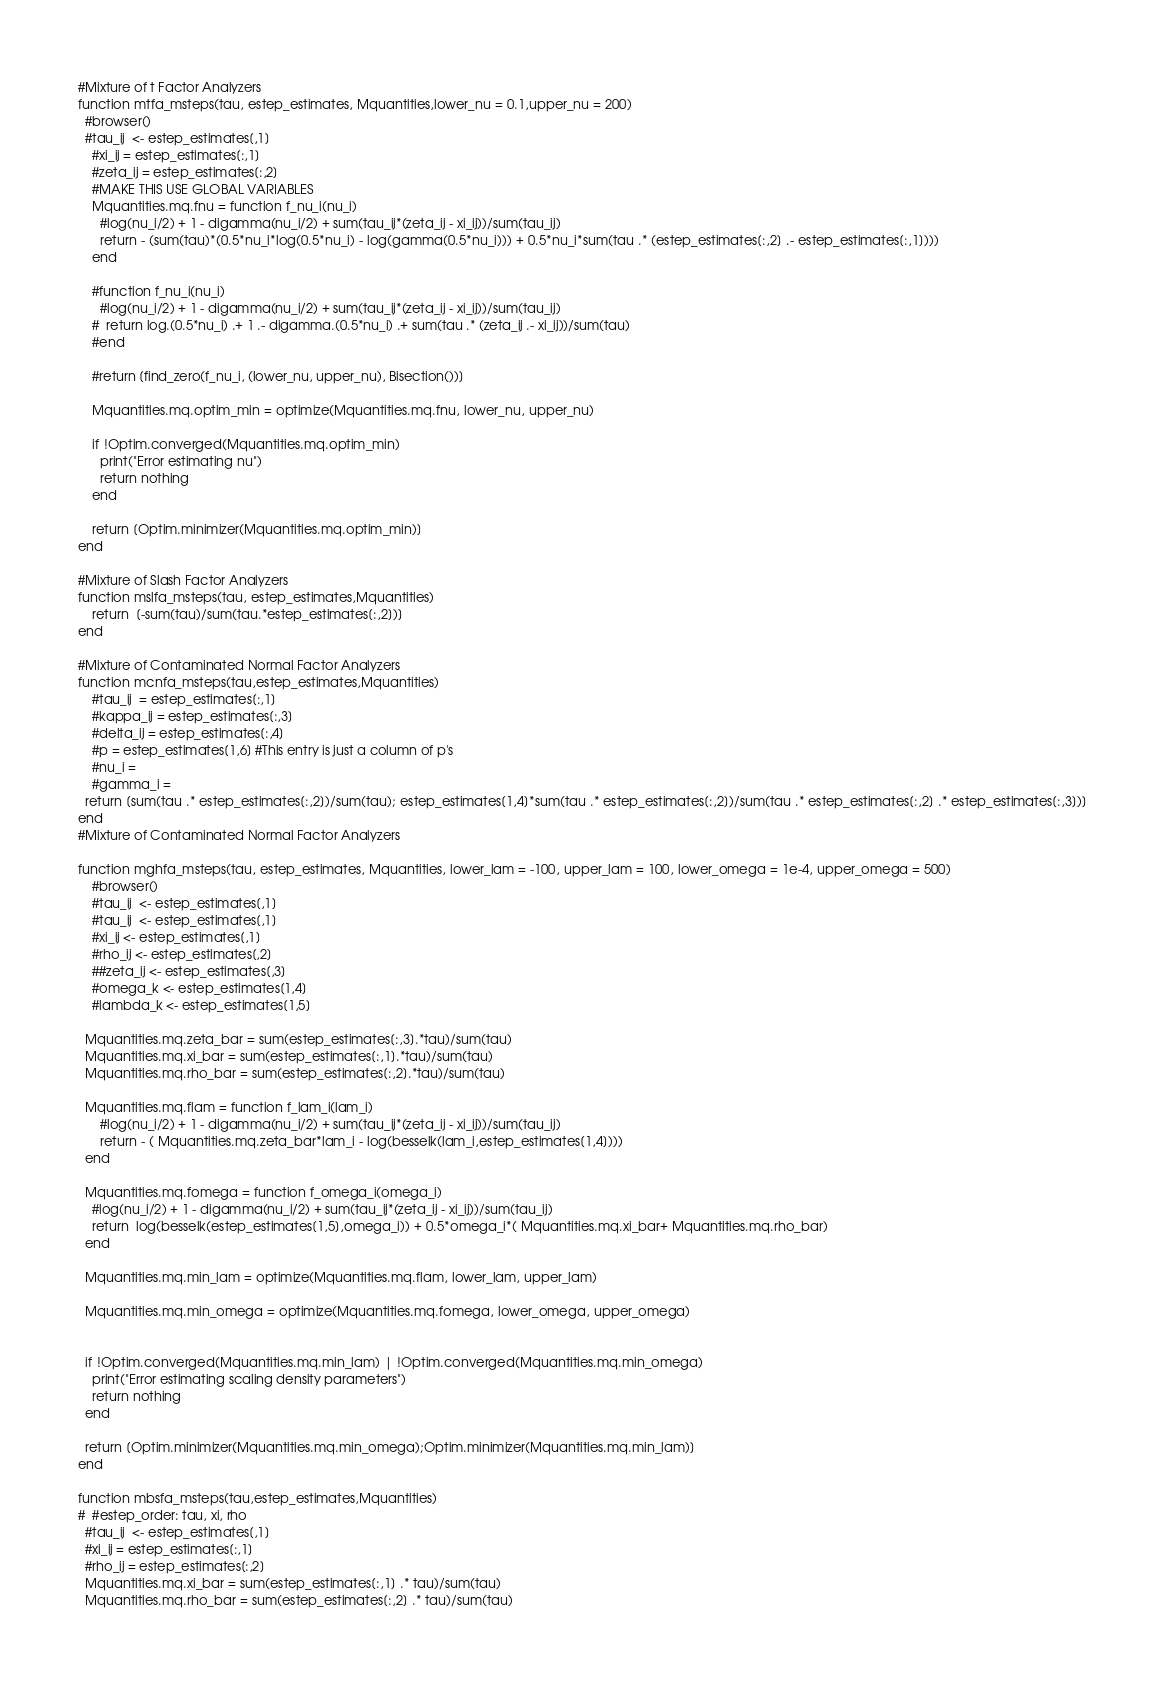<code> <loc_0><loc_0><loc_500><loc_500><_Julia_>#Mixture of t Factor Analyzers
function mtfa_msteps(tau, estep_estimates, Mquantities,lower_nu = 0.1,upper_nu = 200)
  #browser()
  #tau_ij  <- estep_estimates[,1]
    #xi_ij = estep_estimates[:,1]
    #zeta_ij = estep_estimates[:,2]
    #MAKE THIS USE GLOBAL VARIABLES 
    Mquantities.mq.fnu = function f_nu_i(nu_i)
      #log(nu_i/2) + 1 - digamma(nu_i/2) + sum(tau_ij*(zeta_ij - xi_ij))/sum(tau_ij)
      return - (sum(tau)*(0.5*nu_i*log(0.5*nu_i) - log(gamma(0.5*nu_i))) + 0.5*nu_i*sum(tau .* (estep_estimates[:,2] .- estep_estimates[:,1])))
    end

    #function f_nu_i(nu_i)
      #log(nu_i/2) + 1 - digamma(nu_i/2) + sum(tau_ij*(zeta_ij - xi_ij))/sum(tau_ij)
    #  return log.(0.5*nu_i) .+ 1 .- digamma.(0.5*nu_i) .+ sum(tau .* (zeta_ij .- xi_ij))/sum(tau) 
    #end

    #return [find_zero(f_nu_i, (lower_nu, upper_nu), Bisection())]

    Mquantities.mq.optim_min = optimize(Mquantities.mq.fnu, lower_nu, upper_nu)

    if !Optim.converged(Mquantities.mq.optim_min)
      print("Error estimating nu")
      return nothing
    end

    return [Optim.minimizer(Mquantities.mq.optim_min)]
end  

#Mixture of Slash Factor Analyzers 
function mslfa_msteps(tau, estep_estimates,Mquantities)
    return  [-sum(tau)/sum(tau.*estep_estimates[:,2])]
end

#Mixture of Contaminated Normal Factor Analyzers
function mcnfa_msteps(tau,estep_estimates,Mquantities)
    #tau_ij  = estep_estimates[:,1]
    #kappa_ij = estep_estimates[:,3]
    #delta_ij = estep_estimates[:,4]
    #p = estep_estimates[1,6] #This entry is just a column of p's 
    #nu_i = 
    #gamma_i = 
  return [sum(tau .* estep_estimates[:,2])/sum(tau); estep_estimates[1,4]*sum(tau .* estep_estimates[:,2])/sum(tau .* estep_estimates[:,2] .* estep_estimates[:,3])]
end
#Mixture of Contaminated Normal Factor Analyzers

function mghfa_msteps(tau, estep_estimates, Mquantities, lower_lam = -100, upper_lam = 100, lower_omega = 1e-4, upper_omega = 500)
    #browser()
    #tau_ij  <- estep_estimates[,1]
    #tau_ij  <- estep_estimates[,1]
    #xi_ij <- estep_estimates[,1]
    #rho_ij <- estep_estimates[,2]
    ##zeta_ij <- estep_estimates[,3]
    #omega_k <- estep_estimates[1,4]
    #lambda_k <- estep_estimates[1,5] 

  Mquantities.mq.zeta_bar = sum(estep_estimates[:,3].*tau)/sum(tau)
  Mquantities.mq.xi_bar = sum(estep_estimates[:,1].*tau)/sum(tau)
  Mquantities.mq.rho_bar = sum(estep_estimates[:,2].*tau)/sum(tau)
  
  Mquantities.mq.flam = function f_lam_i(lam_i)
      #log(nu_i/2) + 1 - digamma(nu_i/2) + sum(tau_ij*(zeta_ij - xi_ij))/sum(tau_ij)
      return - ( Mquantities.mq.zeta_bar*lam_i - log(besselk(lam_i,estep_estimates[1,4])))
  end

  Mquantities.mq.fomega = function f_omega_i(omega_i)
    #log(nu_i/2) + 1 - digamma(nu_i/2) + sum(tau_ij*(zeta_ij - xi_ij))/sum(tau_ij)
    return  log(besselk(estep_estimates[1,5],omega_i)) + 0.5*omega_i*( Mquantities.mq.xi_bar+ Mquantities.mq.rho_bar)
  end

  Mquantities.mq.min_lam = optimize(Mquantities.mq.flam, lower_lam, upper_lam)
  
  Mquantities.mq.min_omega = optimize(Mquantities.mq.fomega, lower_omega, upper_omega)


  if !Optim.converged(Mquantities.mq.min_lam) | !Optim.converged(Mquantities.mq.min_omega)
    print("Error estimating scaling density parameters")
    return nothing
  end

  return [Optim.minimizer(Mquantities.mq.min_omega);Optim.minimizer(Mquantities.mq.min_lam)]
end  
  
function mbsfa_msteps(tau,estep_estimates,Mquantities)
#  #estep_order: tau, xi, rho
  #tau_ij  <- estep_estimates[,1]
  #xi_ij = estep_estimates[:,1] 
  #rho_ij = estep_estimates[:,2] 
  Mquantities.mq.xi_bar = sum(estep_estimates[:,1] .* tau)/sum(tau)
  Mquantities.mq.rho_bar = sum(estep_estimates[:,2] .* tau)/sum(tau)</code> 